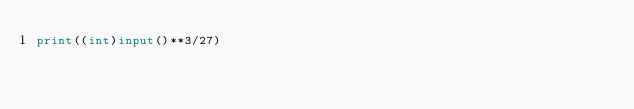<code> <loc_0><loc_0><loc_500><loc_500><_Python_>print((int)input()**3/27)</code> 